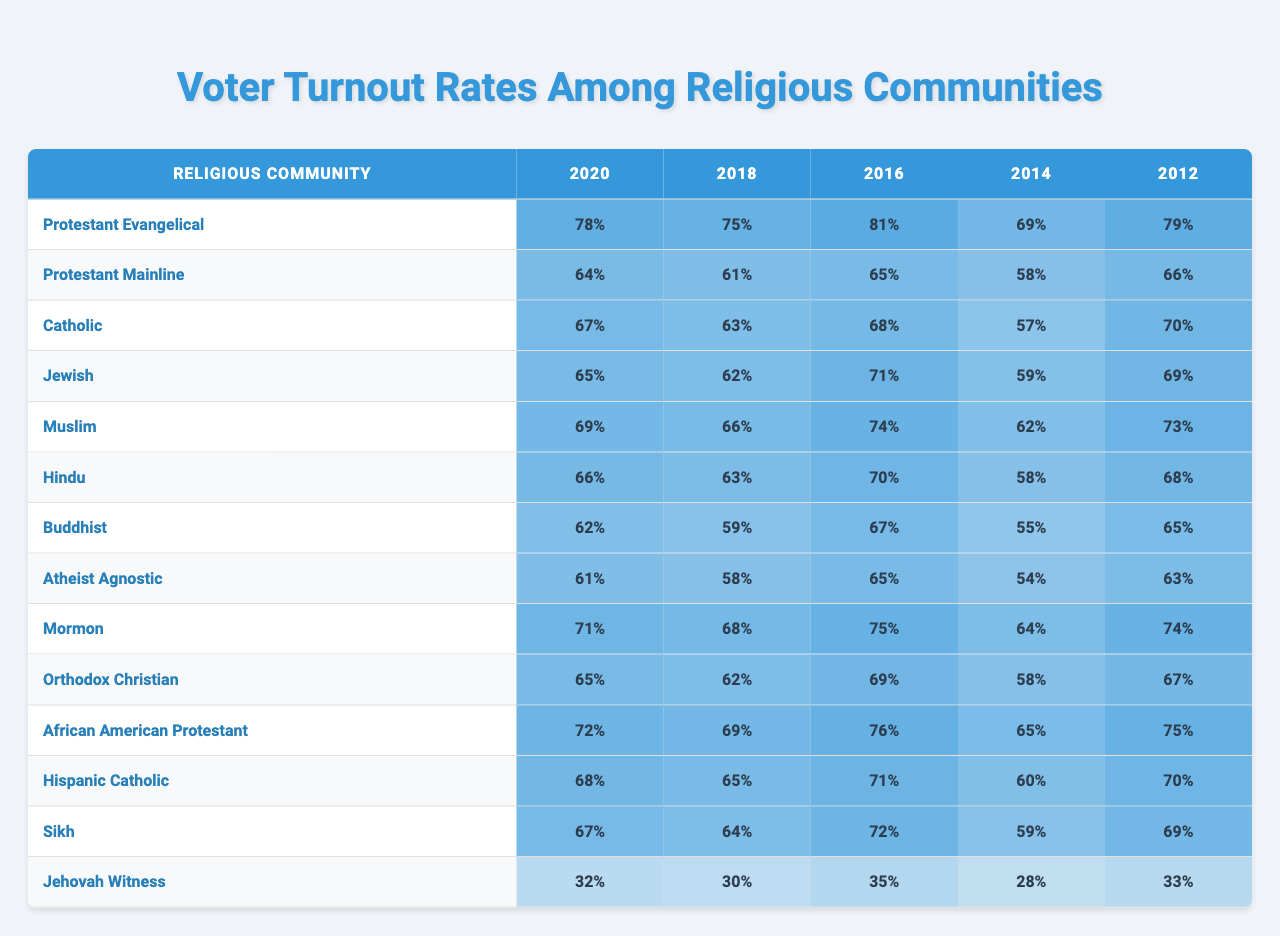What was the voter turnout rate for Jewish voters in 2020? In 2020, the table indicates that the voter turnout rate for Jewish voters was 65%.
Answer: 65% Which religious community had the highest voter turnout in 2016? Looking at the table for 2016, the Protestant Evangelical community had the highest turnout at 81%.
Answer: Protestant Evangelical What is the average voter turnout for the Muslim community over the years presented? Adding the turnout rates for the Muslim community (69 + 66 + 74 + 62 + 73) gives a total of 344. Dividing by the number of election years (5), the average is 344/5 = 68.8%.
Answer: 68.8% Did the voter turnout for Jehovah's Witnesses exceed 40% in any of the elections? In the table, the highest turnout for Jehovah's Witnesses was 35% in 2016; hence, it never exceeded 40%.
Answer: No What is the difference in voter turnout between Hispanic Catholics in 2018 and Buddhists in the same year? In 2018, Hispanic Catholics had a turnout of 65%, while Buddhists had 59%. The difference is 65 - 59 = 6%.
Answer: 6% Which two religious communities had turnout rates below 35% in any year? The table shows that Jehovah's Witnesses had 32% in 2014 and 30% in 2018. No other community had turnout rates below 35%.
Answer: Jehovah's Witnesses For which religious community was the voter turnout in 2014 the lowest compared to other years? The table reveals that the Jehovah's Witnesses had the lowest turnout in 2014 at 28%. Comparing it to their other numbers shows it was the lowest for this community.
Answer: Jehovah's Witnesses What was the turnout rate for African American Protestants in 2012? In 2012, African American Protestants had a voter turnout rate of 75%.
Answer: 75% Which religious community consistently had the lowest turnout over the years? Examining the table for all years, the Jehovah's Witnesses had the lowest turnout rates across all election years compared to other groups.
Answer: Jehovah's Witnesses What is the median voter turnout rate for the Protestant Evangelical community over the years? The Protestant Evangelical turnout rates are 78, 75, 81, 69, 79. Arranging these in order gives 69, 75, 78, 79, 81. The median, which is the middle value, is 78%.
Answer: 78% 